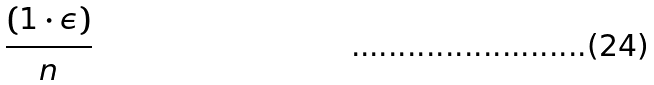Convert formula to latex. <formula><loc_0><loc_0><loc_500><loc_500>\frac { ( 1 \cdot \epsilon ) } { n }</formula> 